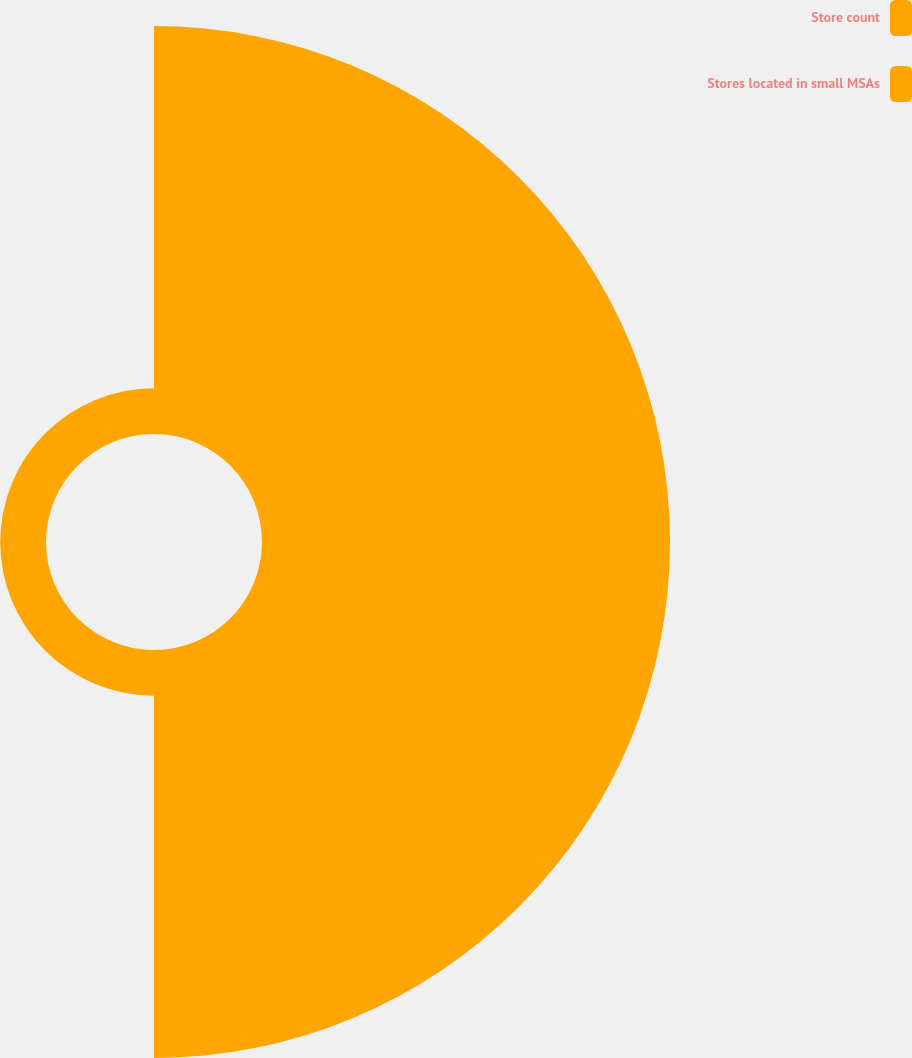Convert chart. <chart><loc_0><loc_0><loc_500><loc_500><pie_chart><fcel>Store count<fcel>Stores located in small MSAs<nl><fcel>89.91%<fcel>10.09%<nl></chart> 